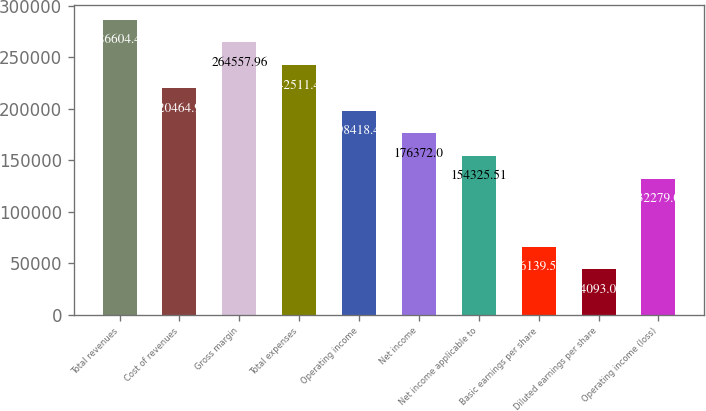<chart> <loc_0><loc_0><loc_500><loc_500><bar_chart><fcel>Total revenues<fcel>Cost of revenues<fcel>Gross margin<fcel>Total expenses<fcel>Operating income<fcel>Net income<fcel>Net income applicable to<fcel>Basic earnings per share<fcel>Diluted earnings per share<fcel>Operating income (loss)<nl><fcel>286604<fcel>220465<fcel>264558<fcel>242511<fcel>198418<fcel>176372<fcel>154326<fcel>66139.6<fcel>44093.1<fcel>132279<nl></chart> 